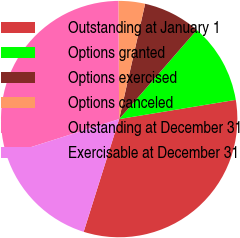Convert chart to OTSL. <chart><loc_0><loc_0><loc_500><loc_500><pie_chart><fcel>Outstanding at January 1<fcel>Options granted<fcel>Options exercised<fcel>Options canceled<fcel>Outstanding at December 31<fcel>Exercisable at December 31<nl><fcel>32.46%<fcel>10.99%<fcel>7.88%<fcel>3.63%<fcel>29.79%<fcel>15.25%<nl></chart> 